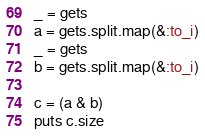Convert code to text. <code><loc_0><loc_0><loc_500><loc_500><_Ruby_>_ = gets
a = gets.split.map(&:to_i)
_ = gets
b = gets.split.map(&:to_i)

c = (a & b)
puts c.size</code> 